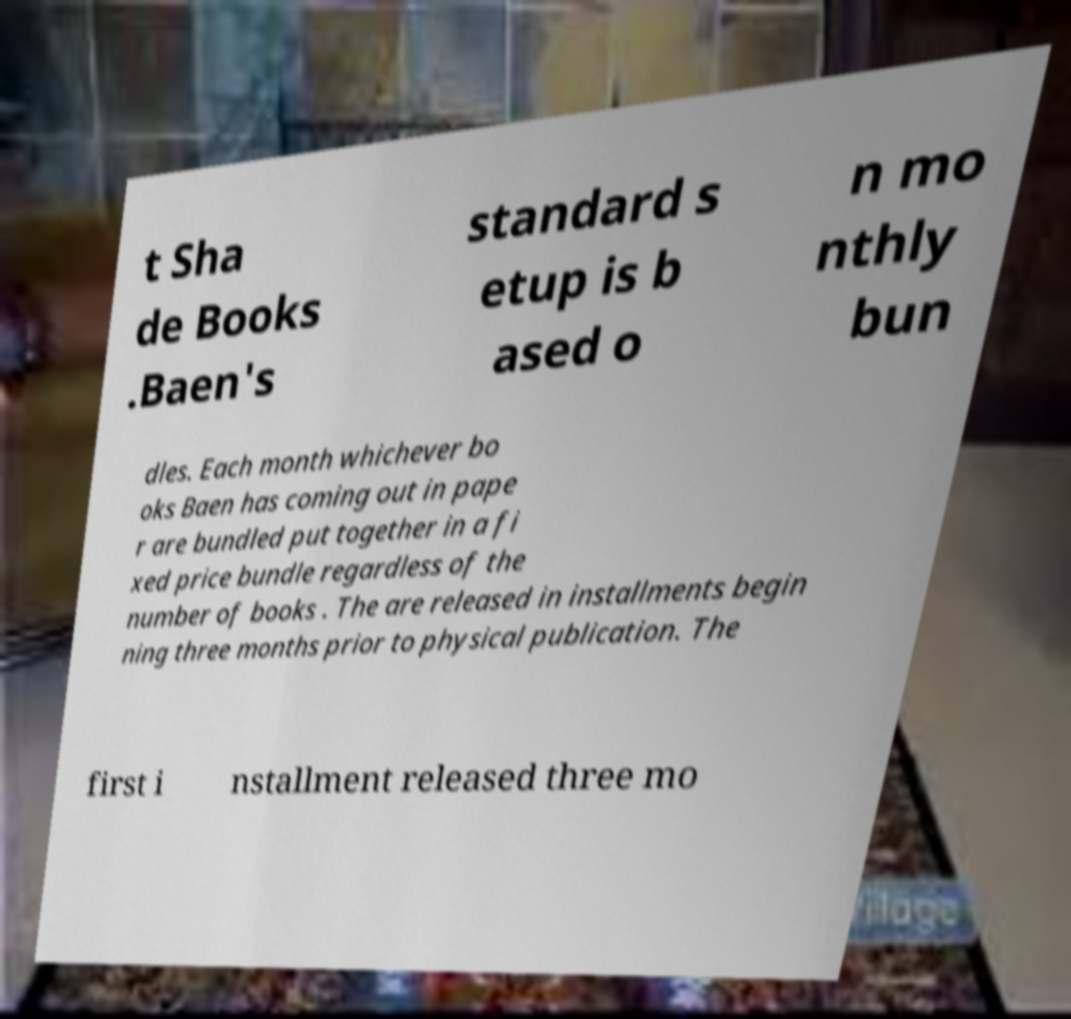For documentation purposes, I need the text within this image transcribed. Could you provide that? t Sha de Books .Baen's standard s etup is b ased o n mo nthly bun dles. Each month whichever bo oks Baen has coming out in pape r are bundled put together in a fi xed price bundle regardless of the number of books . The are released in installments begin ning three months prior to physical publication. The first i nstallment released three mo 